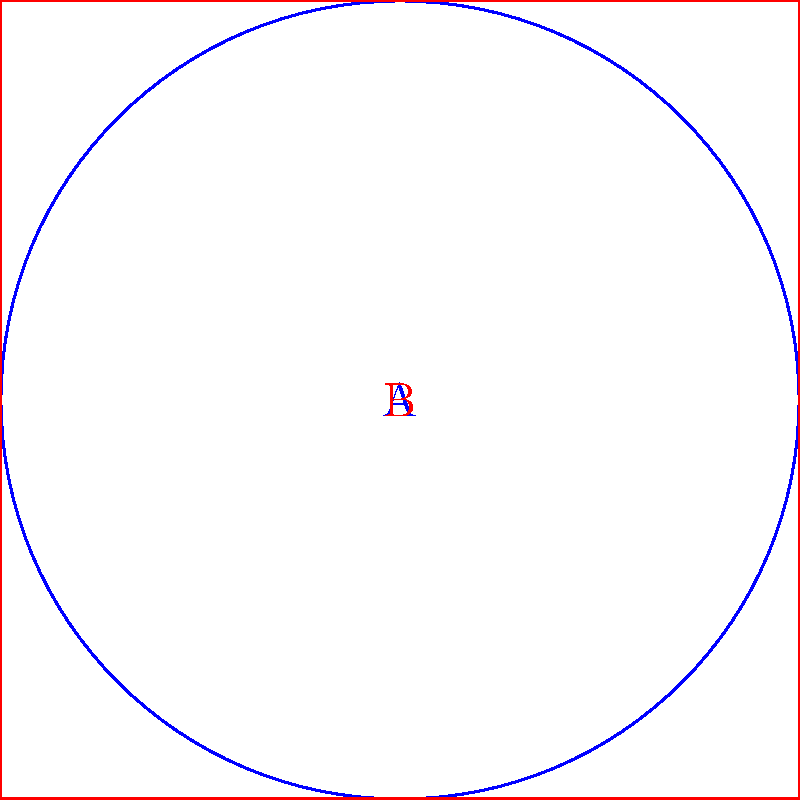Consider the two shapes shown in the diagram: a circle (A) and a square (B). Are these shapes homotopy equivalent? If so, describe a continuous deformation that transforms one into the other. If not, explain why they are not homotopy equivalent. To determine if the circle and square are homotopy equivalent, we need to consider the following steps:

1. Definition: Two topological spaces are homotopy equivalent if there exists a continuous deformation from one to the other.

2. Properties:
   a) Both the circle and square are closed curves in the plane.
   b) Both are simple closed curves (no self-intersections).
   c) Both enclose a single bounded region.

3. Deformation process:
   a) Start with the square.
   b) Continuously "round off" the corners of the square.
   c) Gradually adjust the curvature of the sides until they form a perfect circle.

4. Key points:
   a) This deformation can be done continuously without tearing or cutting.
   b) The reverse process (circle to square) is also possible.
   c) At each step of the deformation, the shape remains a simple closed curve.

5. Formal justification:
   Both shapes are homeomorphic to $S^1$ (the unit circle), which implies they are homotopy equivalent to each other.

6. Connection to music:
   This concept is analogous to how different musical phrases can be variations of the same underlying theme, continuously transformed while maintaining their essential structure.

Therefore, the circle and square are indeed homotopy equivalent.
Answer: Yes, homotopy equivalent. 